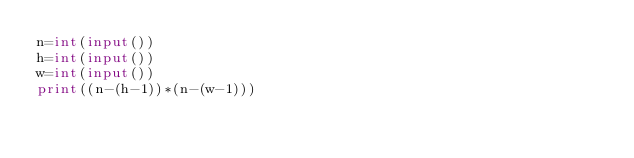Convert code to text. <code><loc_0><loc_0><loc_500><loc_500><_Python_>n=int(input())
h=int(input())
w=int(input())
print((n-(h-1))*(n-(w-1)))</code> 